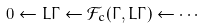Convert formula to latex. <formula><loc_0><loc_0><loc_500><loc_500>0 \leftarrow L \Gamma \leftarrow \mathcal { F } _ { c } ( \Gamma , L \Gamma ) \leftarrow \cdots</formula> 